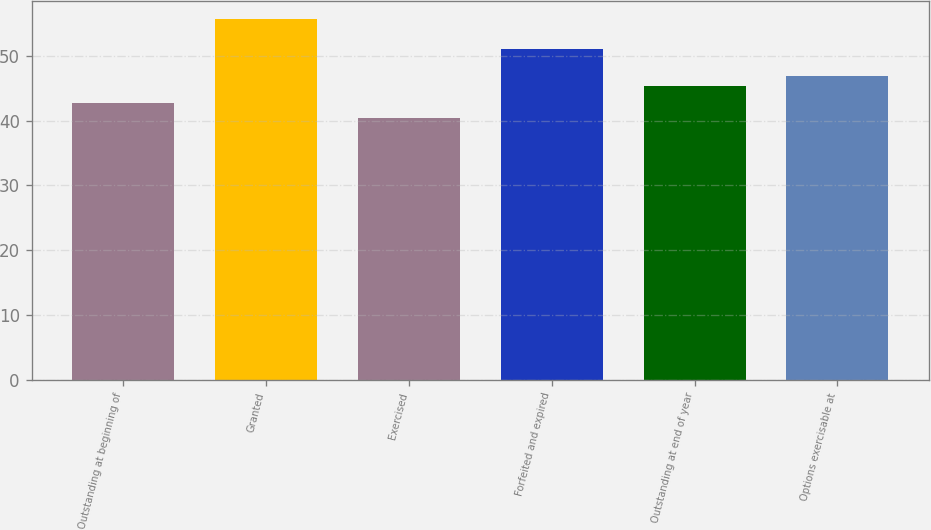Convert chart. <chart><loc_0><loc_0><loc_500><loc_500><bar_chart><fcel>Outstanding at beginning of<fcel>Granted<fcel>Exercised<fcel>Forfeited and expired<fcel>Outstanding at end of year<fcel>Options exercisable at<nl><fcel>42.65<fcel>55.68<fcel>40.38<fcel>51.02<fcel>45.36<fcel>46.89<nl></chart> 